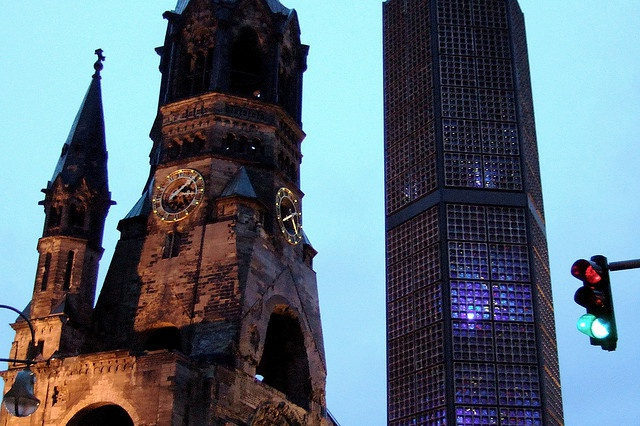Describe the objects in this image and their specific colors. I can see traffic light in lightblue, black, cyan, white, and navy tones, clock in lightblue, maroon, black, brown, and gray tones, and clock in lightblue, black, gray, and maroon tones in this image. 